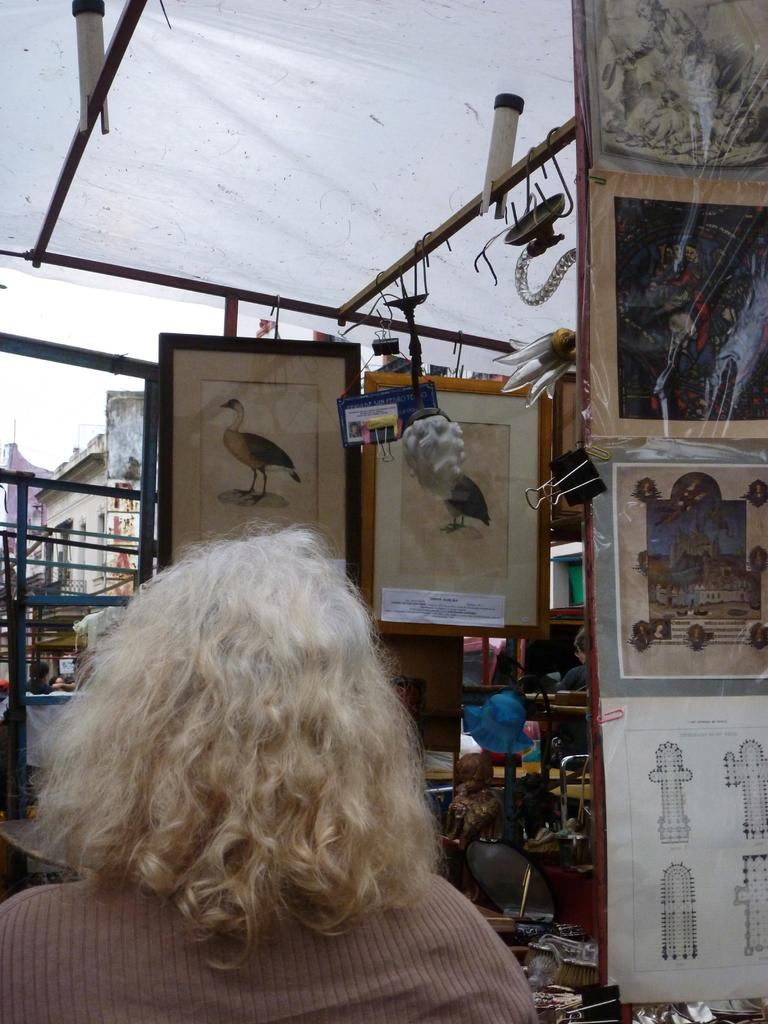What is the main subject of the image? There is a person in the image. Can you describe the person's appearance? The person is wearing clothes. What objects can be seen in the middle of the image? There are photo frames in the middle of the image. What structure is visible at the top of the image? There is a tent at the top of the image. What type of stocking is being used to support the tent in the image? There is no stocking visible in the image, and the tent does not appear to be supported by any stocking. 